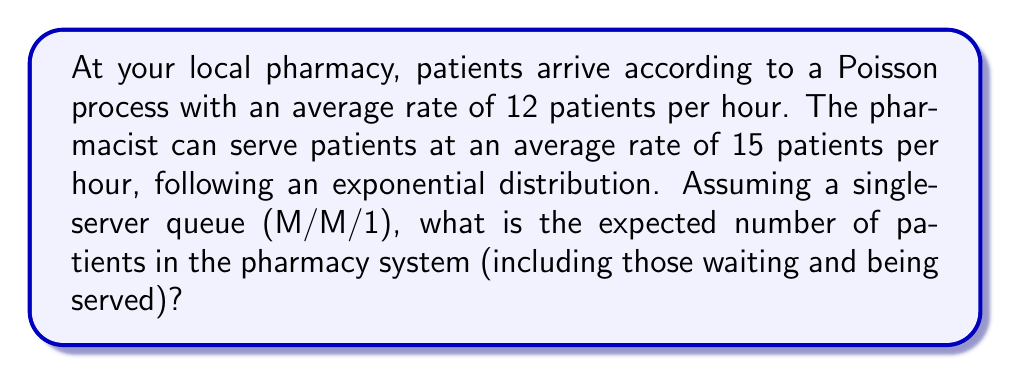Can you solve this math problem? To solve this problem, we'll use the M/M/1 queuing model and follow these steps:

1. Identify the parameters:
   - Arrival rate: $\lambda = 12$ patients/hour
   - Service rate: $\mu = 15$ patients/hour

2. Calculate the utilization factor $\rho$:
   $$\rho = \frac{\lambda}{\mu} = \frac{12}{15} = 0.8$$

3. Use the formula for the expected number of customers in the system (L):
   $$L = \frac{\rho}{1-\rho}$$

4. Substitute the calculated $\rho$ value:
   $$L = \frac{0.8}{1-0.8} = \frac{0.8}{0.2} = 4$$

Therefore, the expected number of patients in the pharmacy system is 4.

This result indicates that, on average, there will be 4 patients in the pharmacy, including those waiting and the one being served.
Answer: 4 patients 